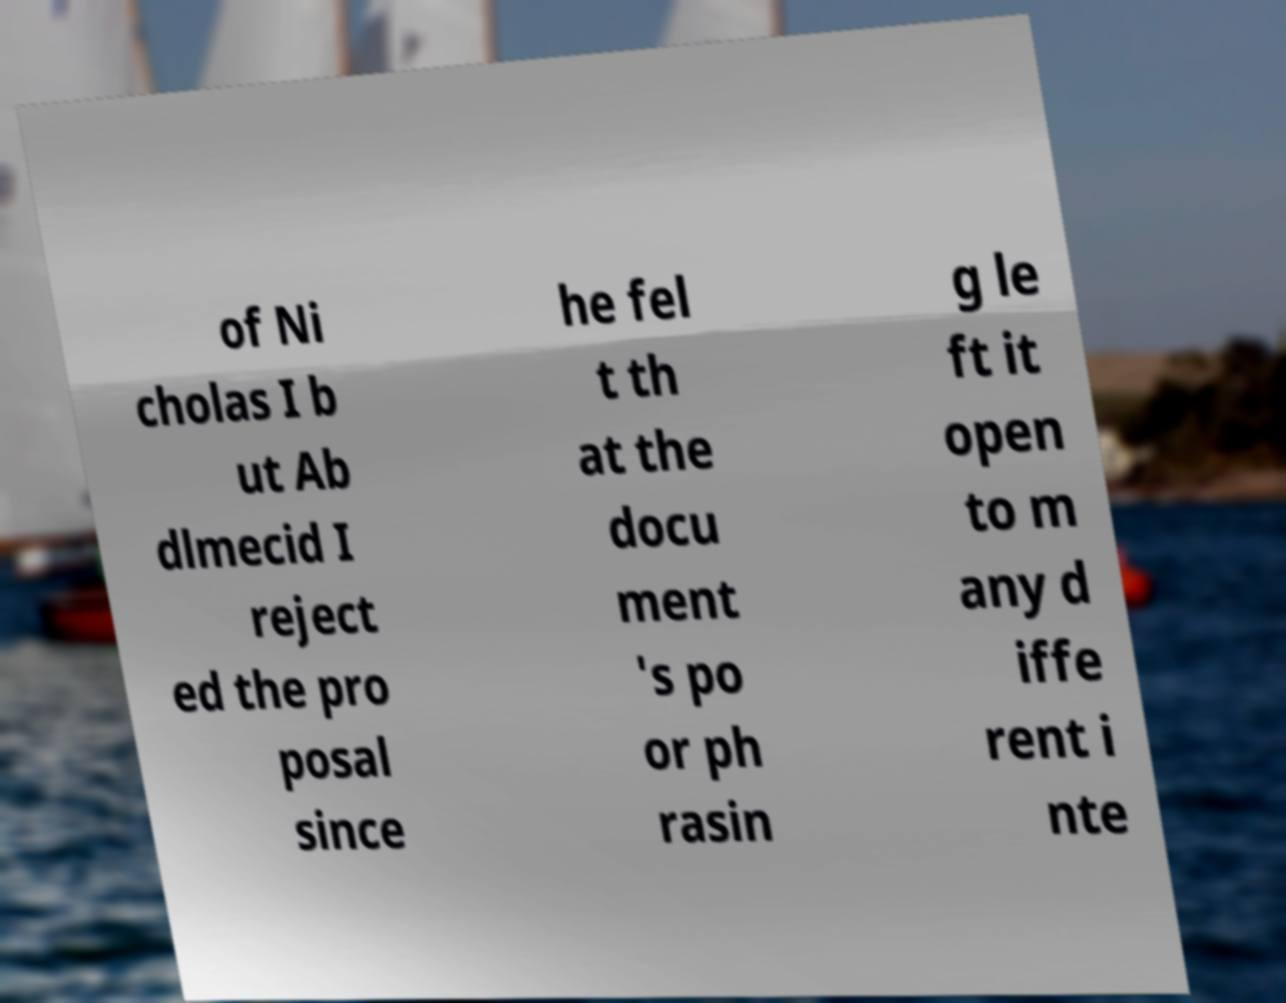Can you read and provide the text displayed in the image?This photo seems to have some interesting text. Can you extract and type it out for me? of Ni cholas I b ut Ab dlmecid I reject ed the pro posal since he fel t th at the docu ment 's po or ph rasin g le ft it open to m any d iffe rent i nte 